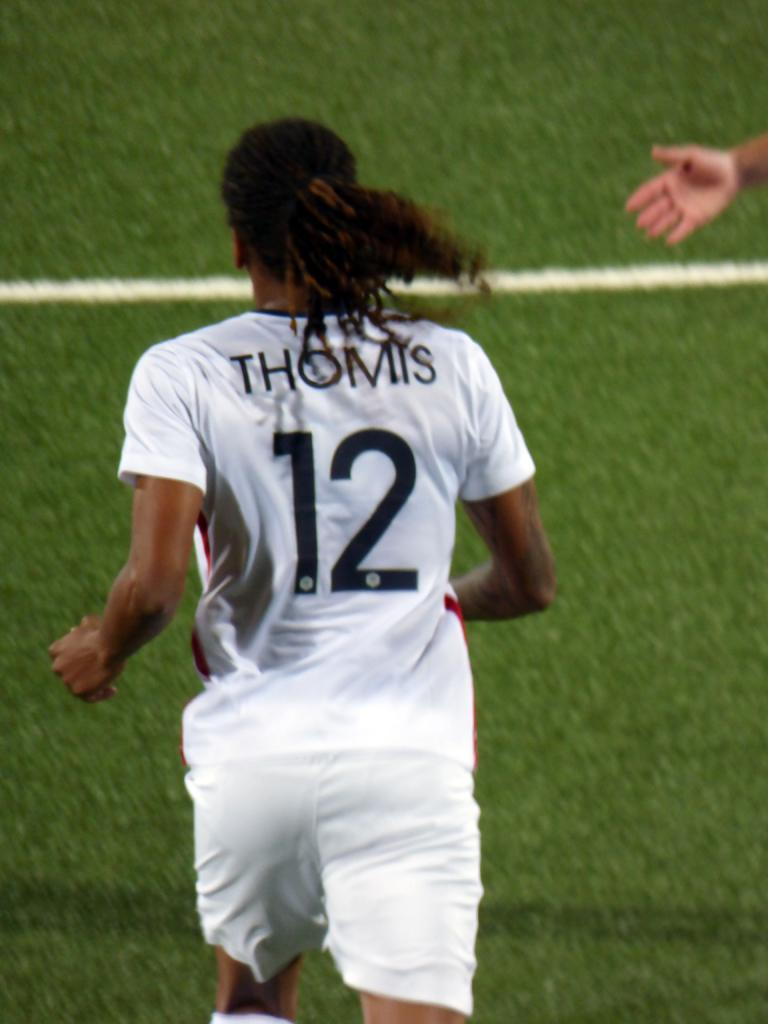<image>
Relay a brief, clear account of the picture shown. White and Black Jersey with the last name Thomis and jersey number twelve. 